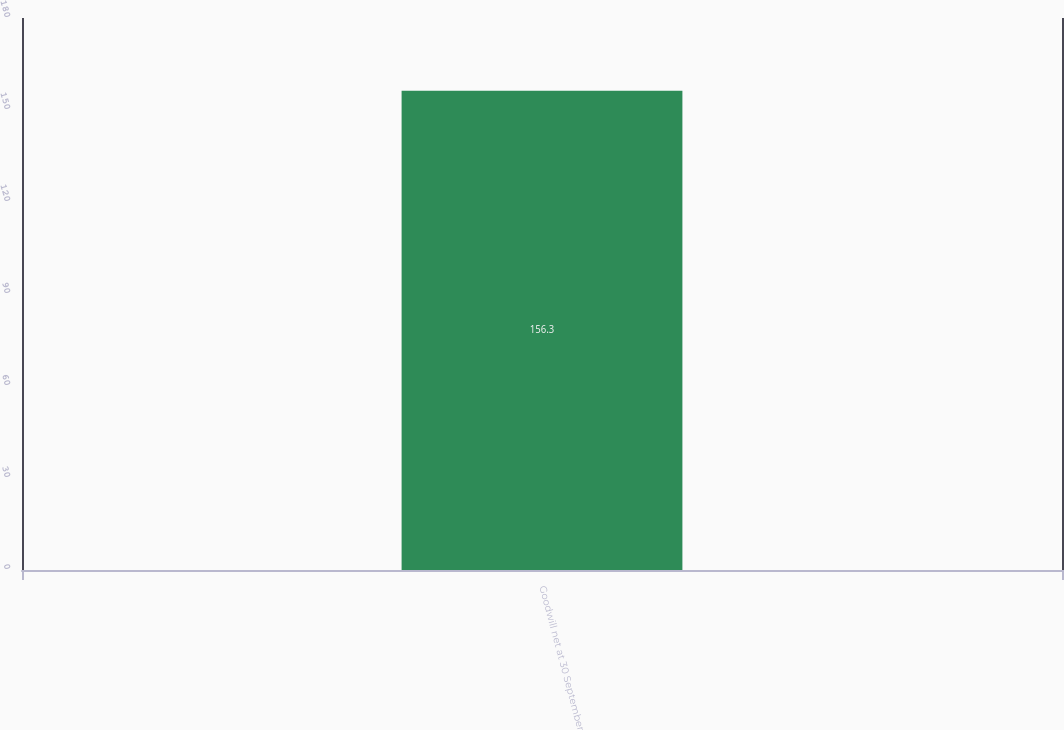Convert chart to OTSL. <chart><loc_0><loc_0><loc_500><loc_500><bar_chart><fcel>Goodwill net at 30 September<nl><fcel>156.3<nl></chart> 